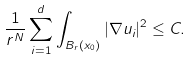<formula> <loc_0><loc_0><loc_500><loc_500>\frac { 1 } { r ^ { N } } \sum _ { i = 1 } ^ { d } \int _ { B _ { r } ( x _ { 0 } ) } | \nabla u _ { i } | ^ { 2 } \leq C .</formula> 